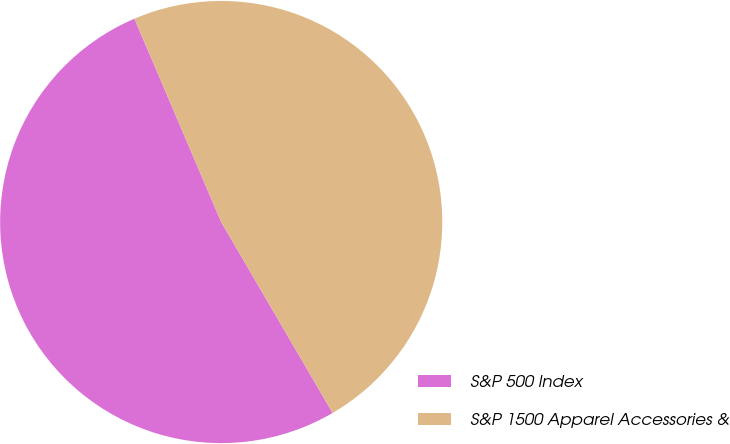<chart> <loc_0><loc_0><loc_500><loc_500><pie_chart><fcel>S&P 500 Index<fcel>S&P 1500 Apparel Accessories &<nl><fcel>51.99%<fcel>48.01%<nl></chart> 